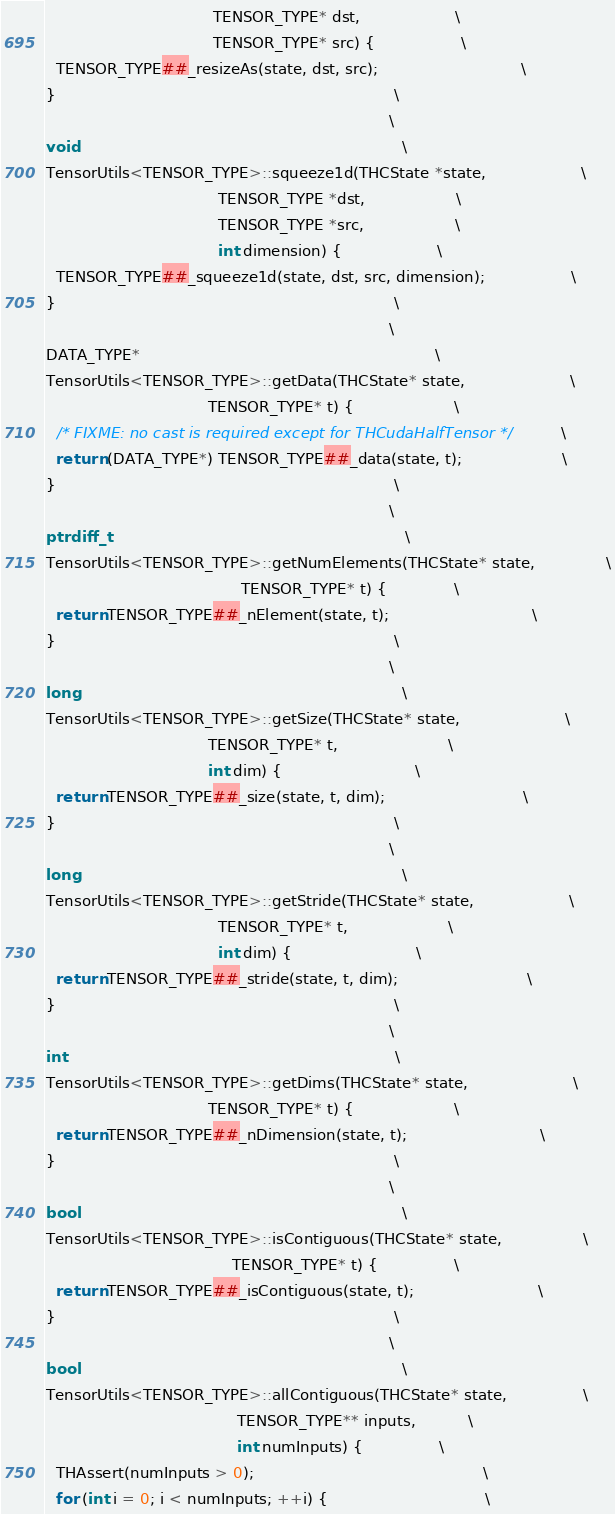Convert code to text. <code><loc_0><loc_0><loc_500><loc_500><_Cuda_>                                   TENSOR_TYPE* dst,                    \
                                   TENSOR_TYPE* src) {                  \
  TENSOR_TYPE##_resizeAs(state, dst, src);                              \
}                                                                       \
                                                                        \
void                                                                    \
TensorUtils<TENSOR_TYPE>::squeeze1d(THCState *state,                    \
                                    TENSOR_TYPE *dst,                   \
                                    TENSOR_TYPE *src,                   \
                                    int dimension) {                    \
  TENSOR_TYPE##_squeeze1d(state, dst, src, dimension);                  \
}                                                                       \
                                                                        \
DATA_TYPE*                                                              \
TensorUtils<TENSOR_TYPE>::getData(THCState* state,                      \
                                  TENSOR_TYPE* t) {                     \
  /* FIXME: no cast is required except for THCudaHalfTensor */          \
  return (DATA_TYPE*) TENSOR_TYPE##_data(state, t);                     \
}                                                                       \
                                                                        \
ptrdiff_t                                                               \
TensorUtils<TENSOR_TYPE>::getNumElements(THCState* state,               \
                                         TENSOR_TYPE* t) {              \
  return TENSOR_TYPE##_nElement(state, t);                              \
}                                                                       \
                                                                        \
long                                                                    \
TensorUtils<TENSOR_TYPE>::getSize(THCState* state,                      \
                                  TENSOR_TYPE* t,                       \
                                  int dim) {                            \
  return TENSOR_TYPE##_size(state, t, dim);                             \
}                                                                       \
                                                                        \
long                                                                    \
TensorUtils<TENSOR_TYPE>::getStride(THCState* state,                    \
                                    TENSOR_TYPE* t,                     \
                                    int dim) {                          \
  return TENSOR_TYPE##_stride(state, t, dim);                           \
}                                                                       \
                                                                        \
int                                                                     \
TensorUtils<TENSOR_TYPE>::getDims(THCState* state,                      \
                                  TENSOR_TYPE* t) {                     \
  return TENSOR_TYPE##_nDimension(state, t);                            \
}                                                                       \
                                                                        \
bool                                                                    \
TensorUtils<TENSOR_TYPE>::isContiguous(THCState* state,                 \
                                       TENSOR_TYPE* t) {                \
  return TENSOR_TYPE##_isContiguous(state, t);                          \
}                                                                       \
                                                                        \
bool                                                                    \
TensorUtils<TENSOR_TYPE>::allContiguous(THCState* state,                \
                                        TENSOR_TYPE** inputs,           \
                                        int numInputs) {                \
  THAssert(numInputs > 0);                                                \
  for (int i = 0; i < numInputs; ++i) {                                 \</code> 